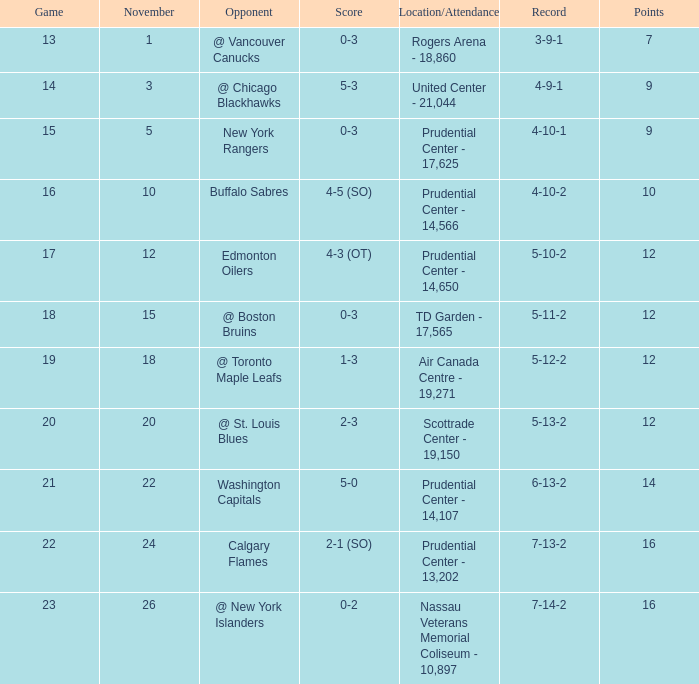What is the total number of locations that had a score of 1-3? 1.0. 